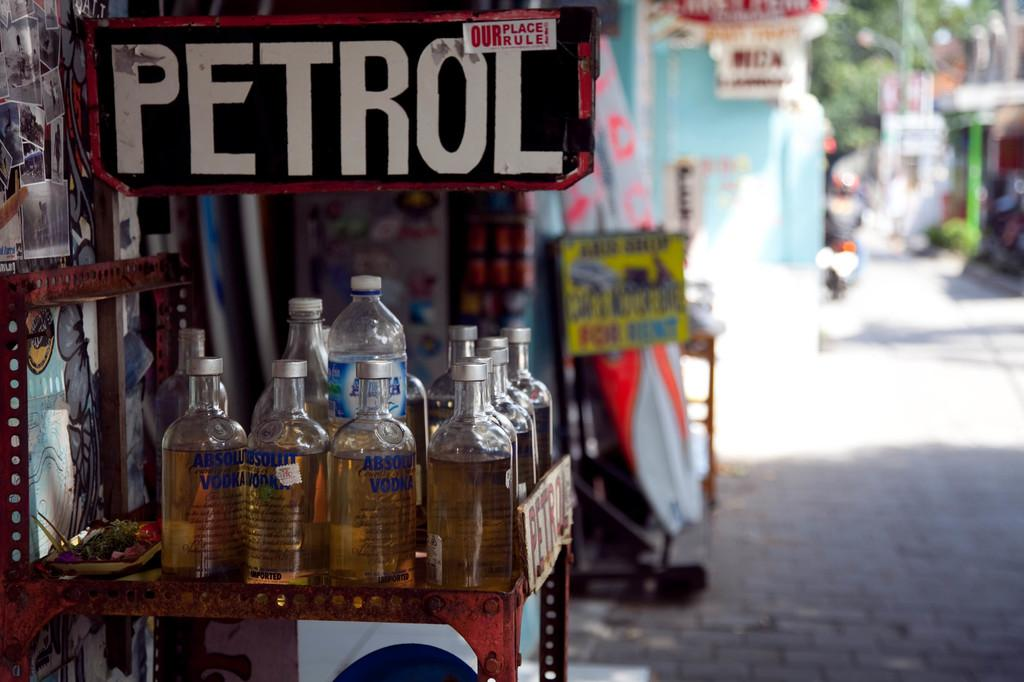<image>
Share a concise interpretation of the image provided. Bottles of Absolut vodka with a dark liquid in them and a sign that says Petrol oer them. 